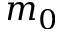Convert formula to latex. <formula><loc_0><loc_0><loc_500><loc_500>m _ { 0 }</formula> 